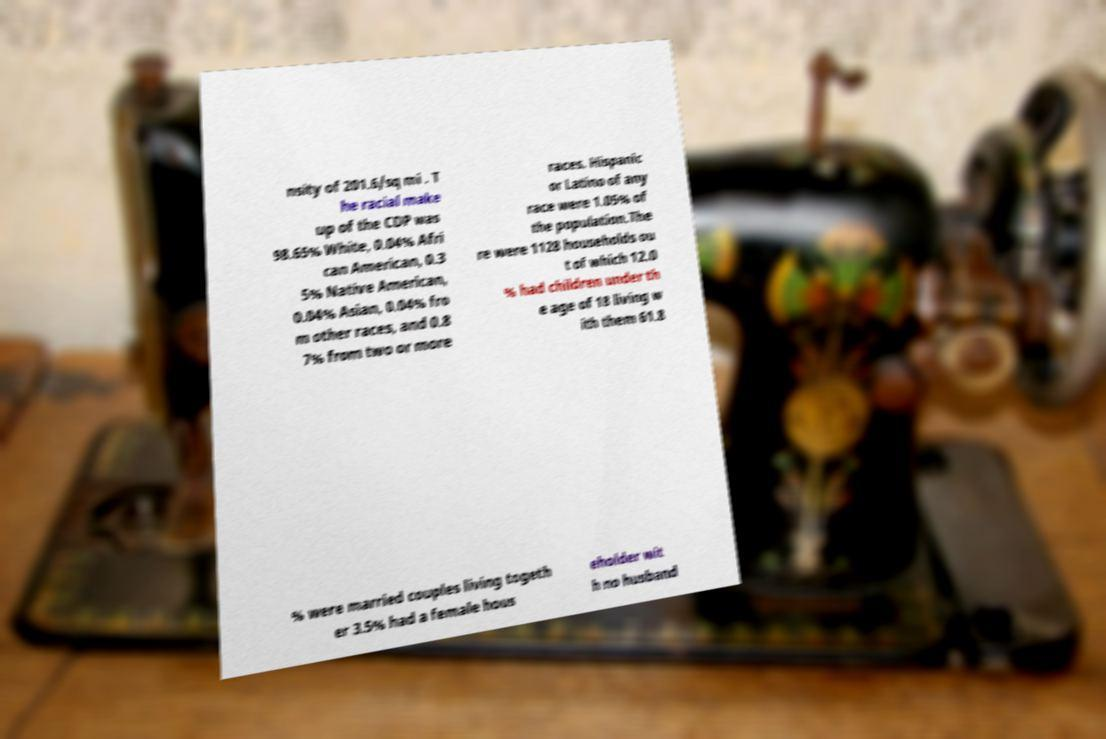What messages or text are displayed in this image? I need them in a readable, typed format. nsity of 201.6/sq mi . T he racial make up of the CDP was 98.65% White, 0.04% Afri can American, 0.3 5% Native American, 0.04% Asian, 0.04% fro m other races, and 0.8 7% from two or more races. Hispanic or Latino of any race were 1.05% of the population.The re were 1128 households ou t of which 12.0 % had children under th e age of 18 living w ith them 61.8 % were married couples living togeth er 3.5% had a female hous eholder wit h no husband 